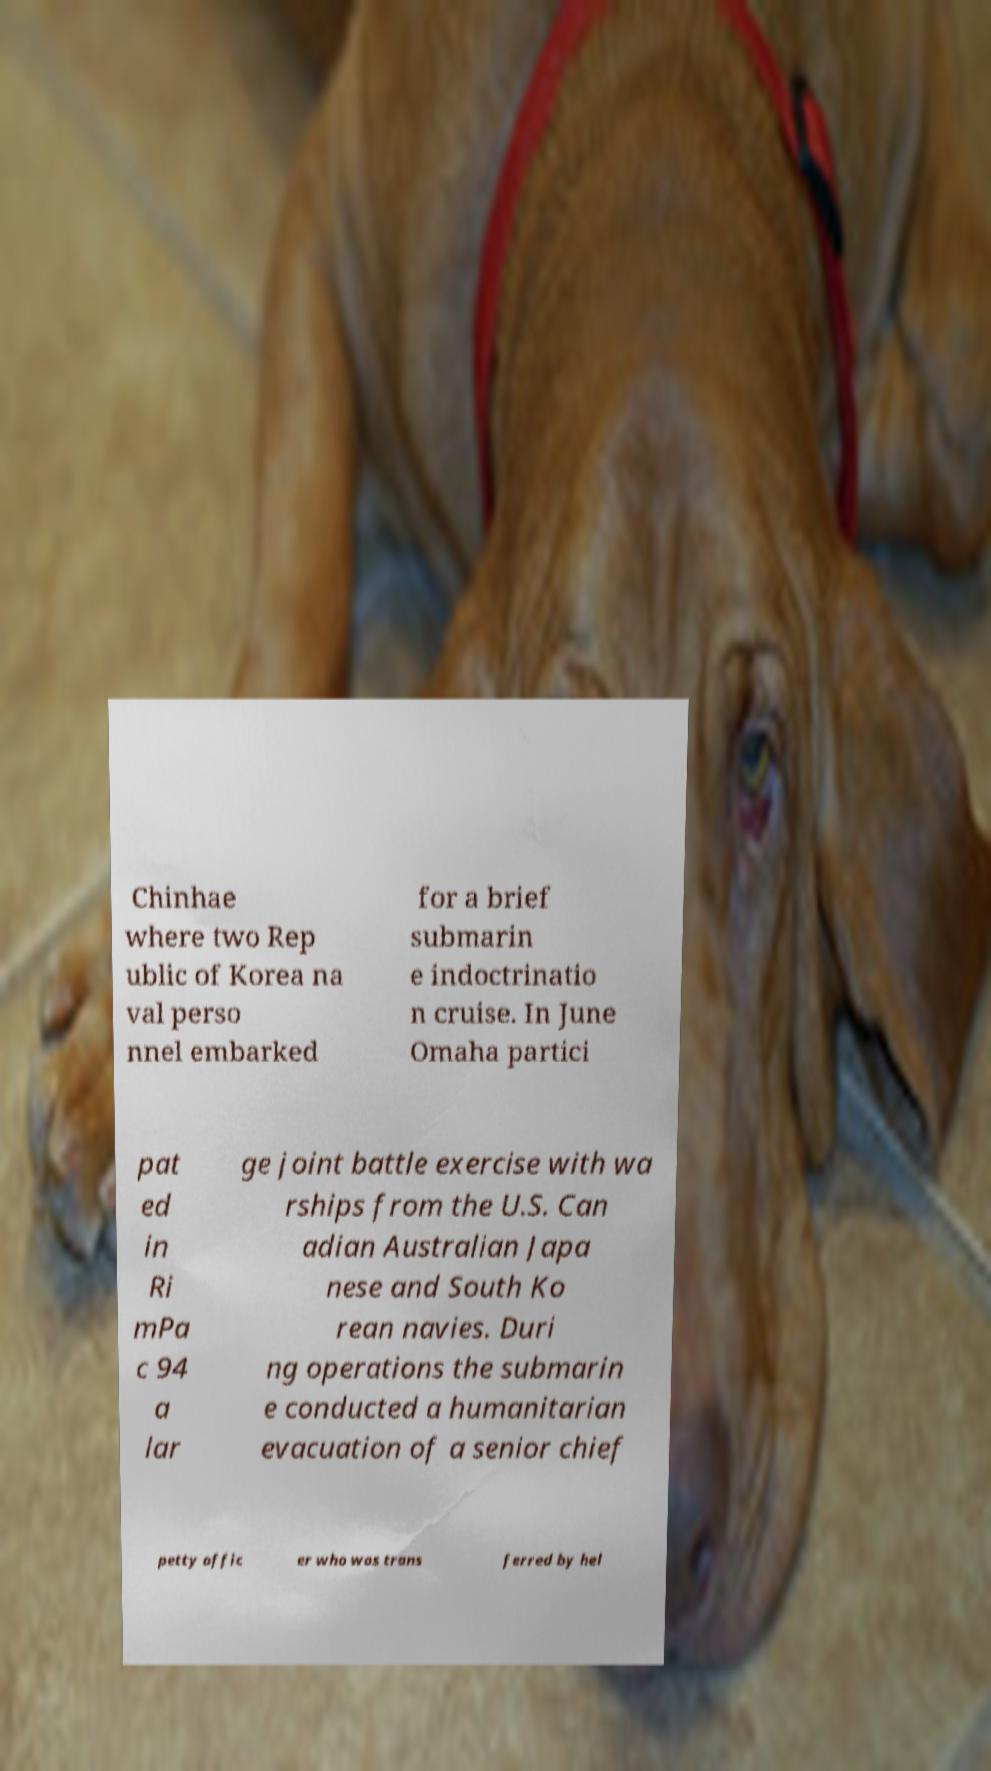For documentation purposes, I need the text within this image transcribed. Could you provide that? Chinhae where two Rep ublic of Korea na val perso nnel embarked for a brief submarin e indoctrinatio n cruise. In June Omaha partici pat ed in Ri mPa c 94 a lar ge joint battle exercise with wa rships from the U.S. Can adian Australian Japa nese and South Ko rean navies. Duri ng operations the submarin e conducted a humanitarian evacuation of a senior chief petty offic er who was trans ferred by hel 